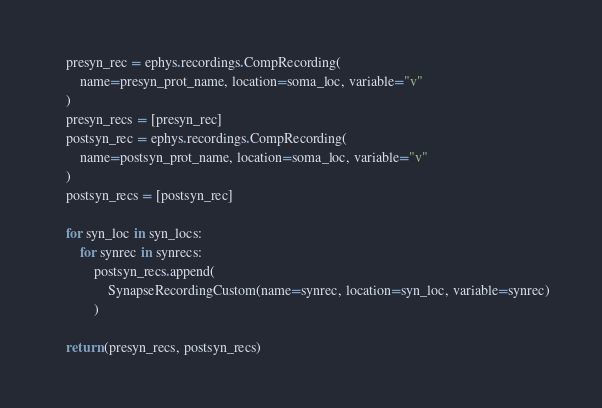Convert code to text. <code><loc_0><loc_0><loc_500><loc_500><_Python_>    presyn_rec = ephys.recordings.CompRecording(
        name=presyn_prot_name, location=soma_loc, variable="v"
    )
    presyn_recs = [presyn_rec]
    postsyn_rec = ephys.recordings.CompRecording(
        name=postsyn_prot_name, location=soma_loc, variable="v"
    )
    postsyn_recs = [postsyn_rec]

    for syn_loc in syn_locs:
        for synrec in synrecs:
            postsyn_recs.append(
                SynapseRecordingCustom(name=synrec, location=syn_loc, variable=synrec)
            )

    return (presyn_recs, postsyn_recs)
</code> 